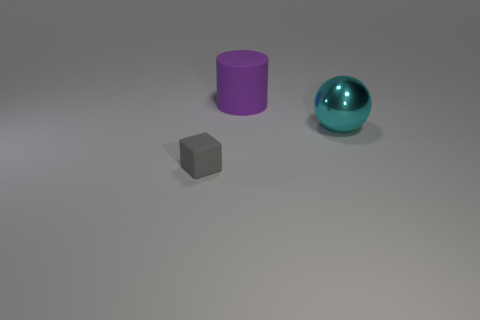Subtract all gray spheres. Subtract all green cylinders. How many spheres are left? 1 Add 1 big matte things. How many objects exist? 4 Subtract all blocks. How many objects are left? 2 Subtract all cyan objects. Subtract all tiny objects. How many objects are left? 1 Add 2 big cylinders. How many big cylinders are left? 3 Add 1 small brown metallic spheres. How many small brown metallic spheres exist? 1 Subtract 0 gray spheres. How many objects are left? 3 